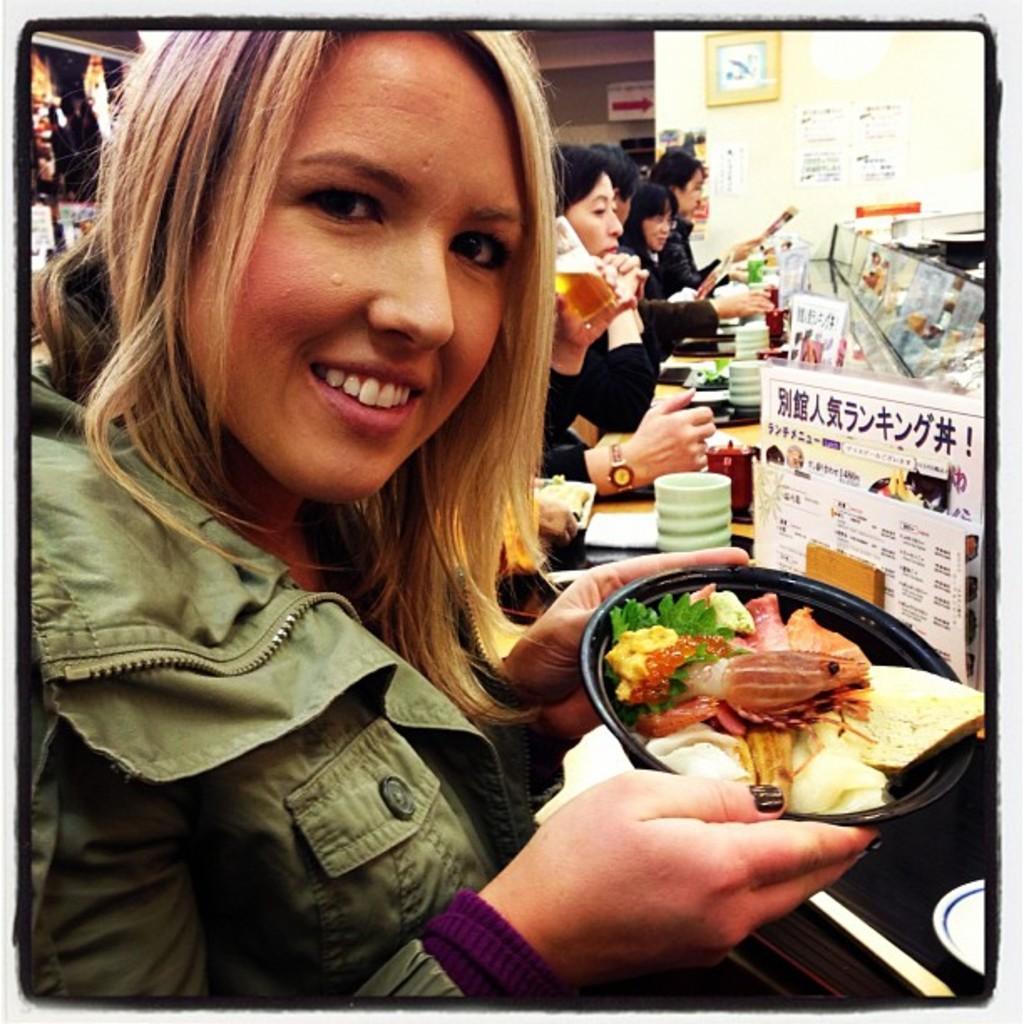Could you give a brief overview of what you see in this image? In this image we can see a woman. She is holding food item in her hand. In the background, we can see people, wall, clock, sign board, cups and poster. 